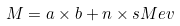<formula> <loc_0><loc_0><loc_500><loc_500>M = a \times b + n \times s M e v</formula> 